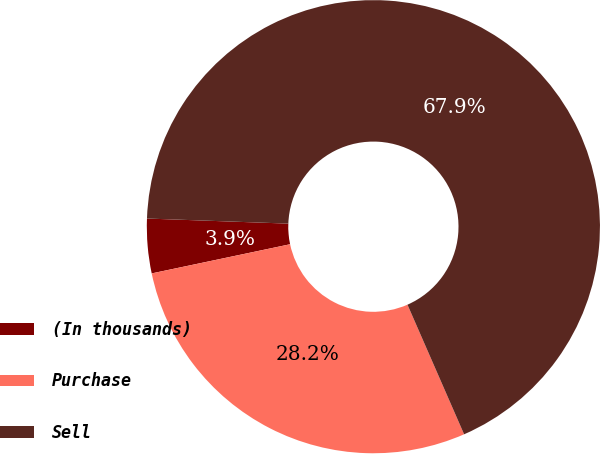Convert chart. <chart><loc_0><loc_0><loc_500><loc_500><pie_chart><fcel>(In thousands)<fcel>Purchase<fcel>Sell<nl><fcel>3.88%<fcel>28.25%<fcel>67.87%<nl></chart> 